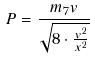Convert formula to latex. <formula><loc_0><loc_0><loc_500><loc_500>P = \frac { m _ { 7 } v } { \sqrt { 8 \cdot \frac { v ^ { 2 } } { x ^ { 2 } } } }</formula> 